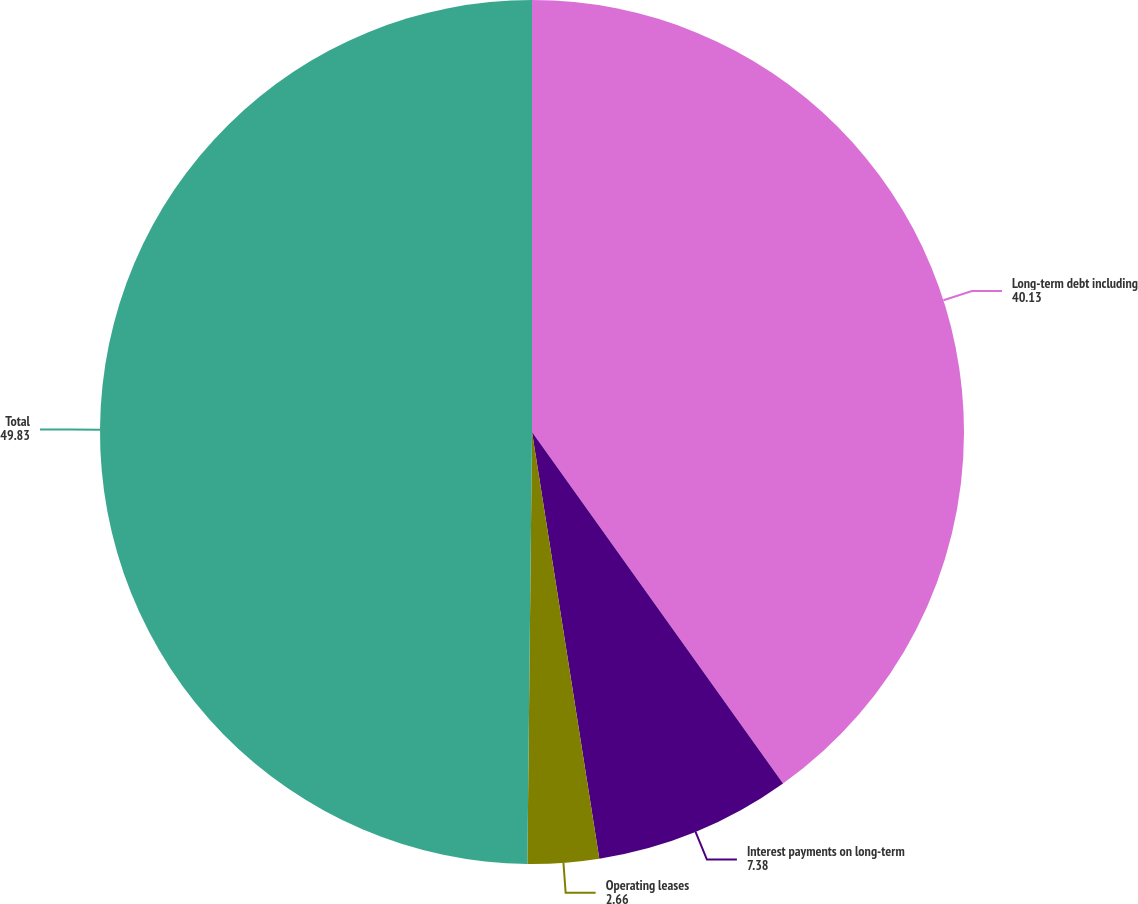<chart> <loc_0><loc_0><loc_500><loc_500><pie_chart><fcel>Long-term debt including<fcel>Interest payments on long-term<fcel>Operating leases<fcel>Total<nl><fcel>40.13%<fcel>7.38%<fcel>2.66%<fcel>49.83%<nl></chart> 